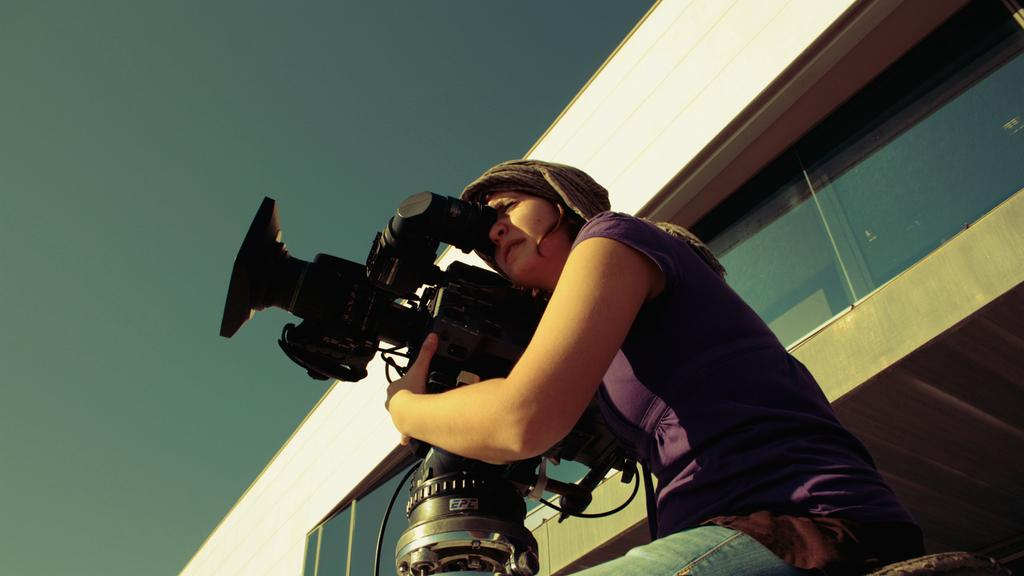Who is the main subject in the image? There is a lady in the image. What is the lady wearing? The lady is wearing a violet t-shirt. What is the lady doing in the image? The lady is sitting and holding a video camera in her hand. What can be seen behind the lady? There is a building behind her. What type of glass is present in the image? There is a window glass in the image. What type of insurance does the lady have for her video camera in the image? There is no information about the lady's insurance for her video camera in the image. How many copies of the video camera does the lady have in the image? There is only one video camera visible in the lady's hand in the image. 